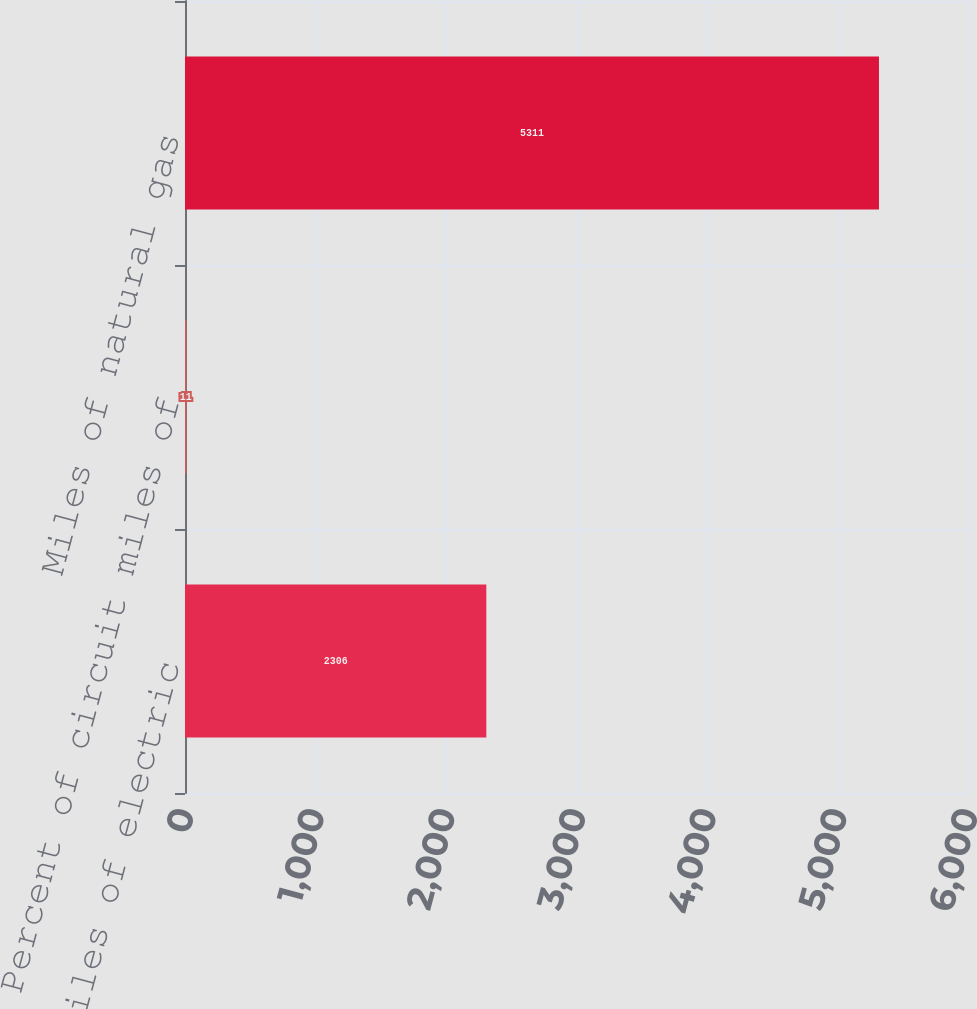Convert chart to OTSL. <chart><loc_0><loc_0><loc_500><loc_500><bar_chart><fcel>Circuit miles of electric<fcel>Percent of circuit miles of<fcel>Miles of natural gas<nl><fcel>2306<fcel>11<fcel>5311<nl></chart> 